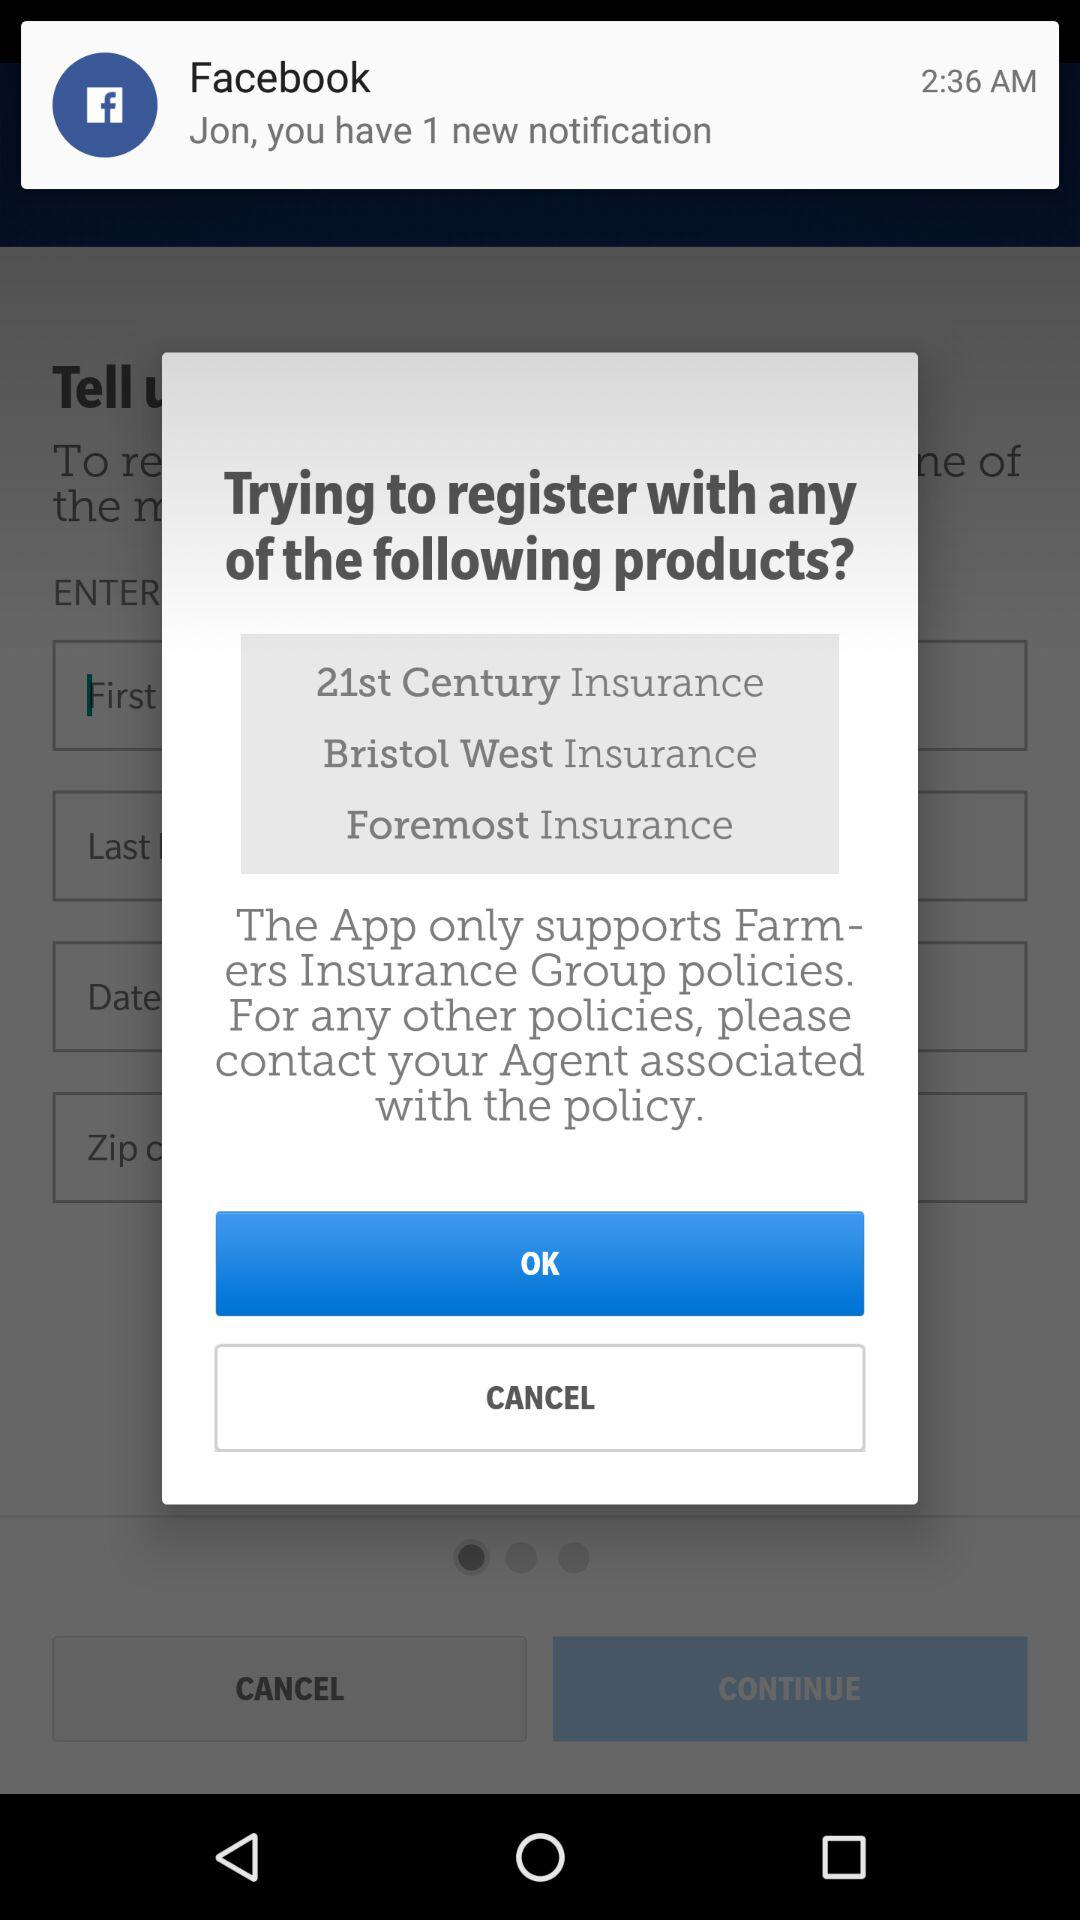What is the time? The time is 2:36 a.m. 